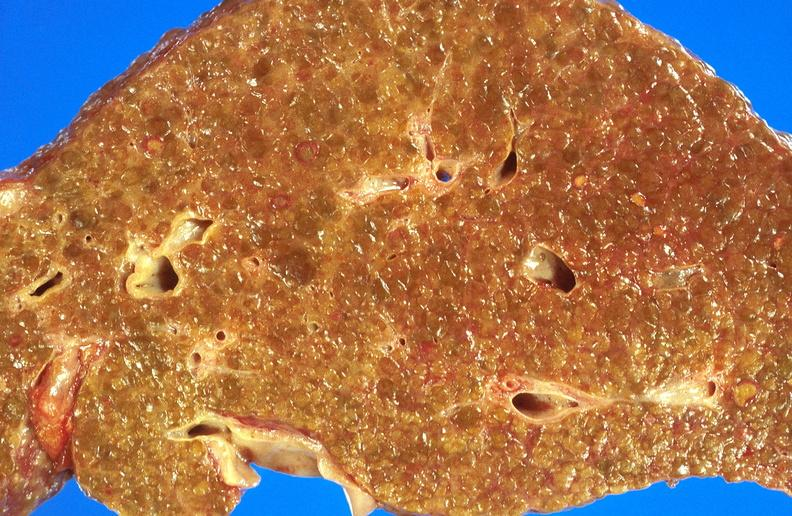what is present?
Answer the question using a single word or phrase. Liver 